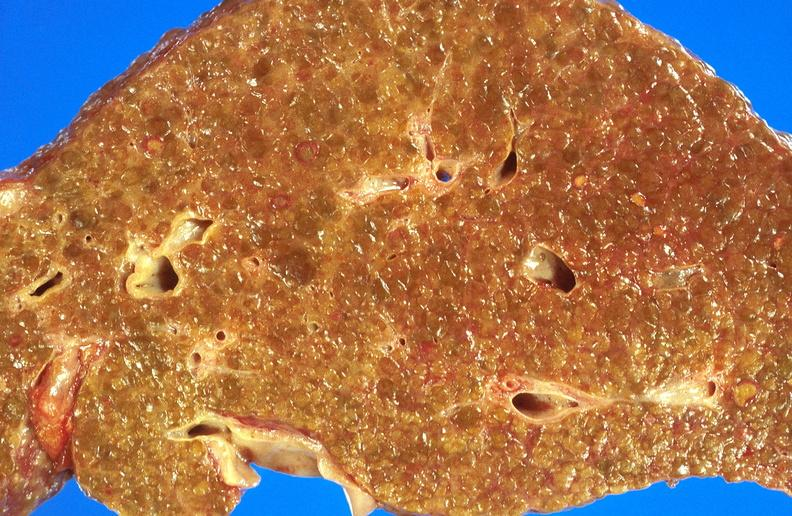what is present?
Answer the question using a single word or phrase. Liver 